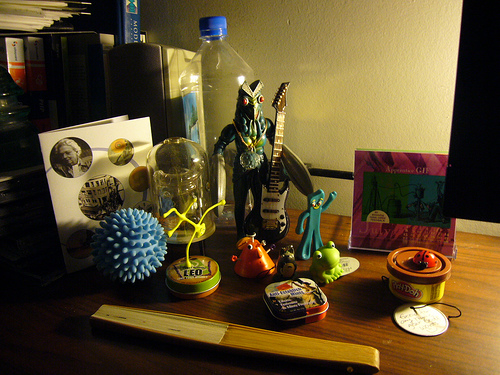<image>
Is the bottle next to the ball? No. The bottle is not positioned next to the ball. They are located in different areas of the scene. Where is the dryer ball in relation to the bottle? Is it in front of the bottle? Yes. The dryer ball is positioned in front of the bottle, appearing closer to the camera viewpoint. 